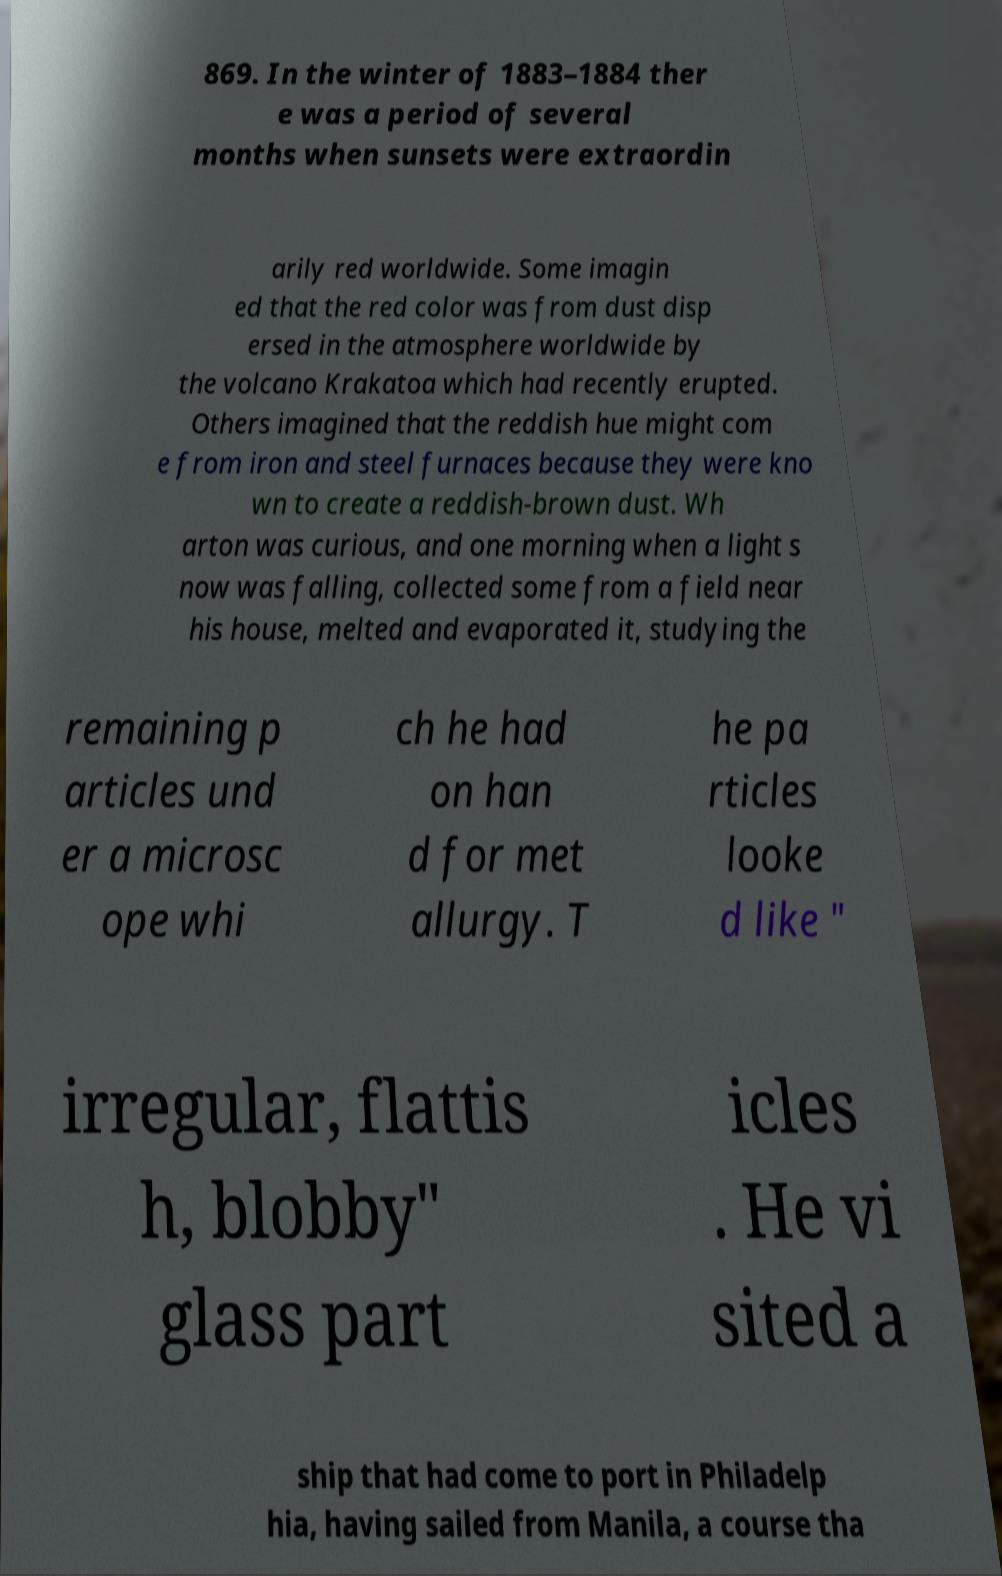Please identify and transcribe the text found in this image. 869. In the winter of 1883–1884 ther e was a period of several months when sunsets were extraordin arily red worldwide. Some imagin ed that the red color was from dust disp ersed in the atmosphere worldwide by the volcano Krakatoa which had recently erupted. Others imagined that the reddish hue might com e from iron and steel furnaces because they were kno wn to create a reddish-brown dust. Wh arton was curious, and one morning when a light s now was falling, collected some from a field near his house, melted and evaporated it, studying the remaining p articles und er a microsc ope whi ch he had on han d for met allurgy. T he pa rticles looke d like " irregular, flattis h, blobby" glass part icles . He vi sited a ship that had come to port in Philadelp hia, having sailed from Manila, a course tha 